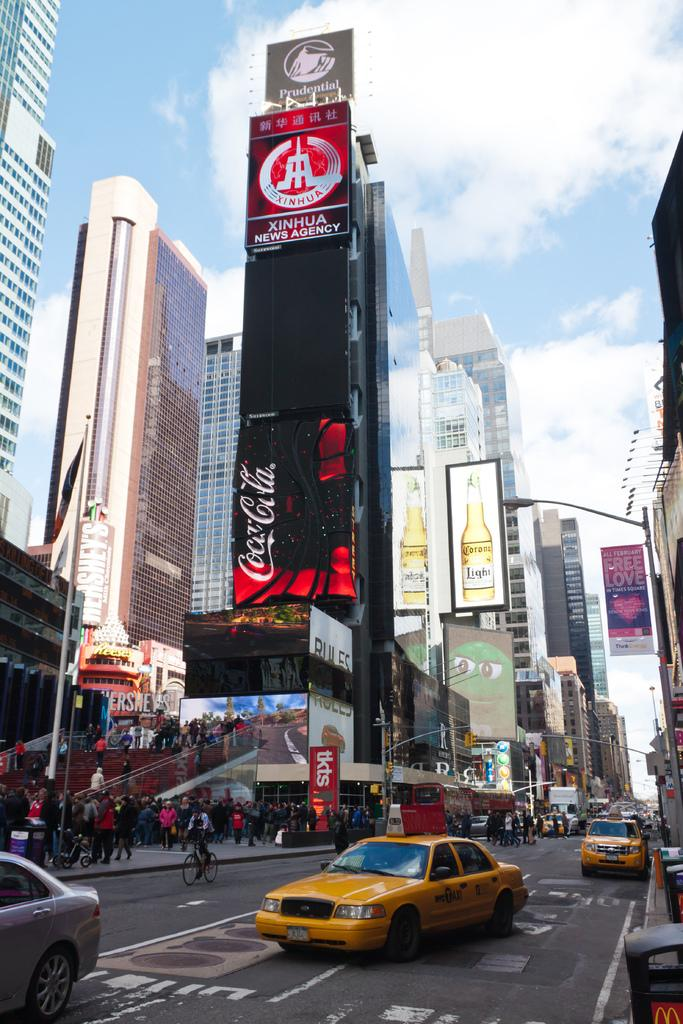<image>
Describe the image concisely. Large black ad for Coca Cola outside in a city. 